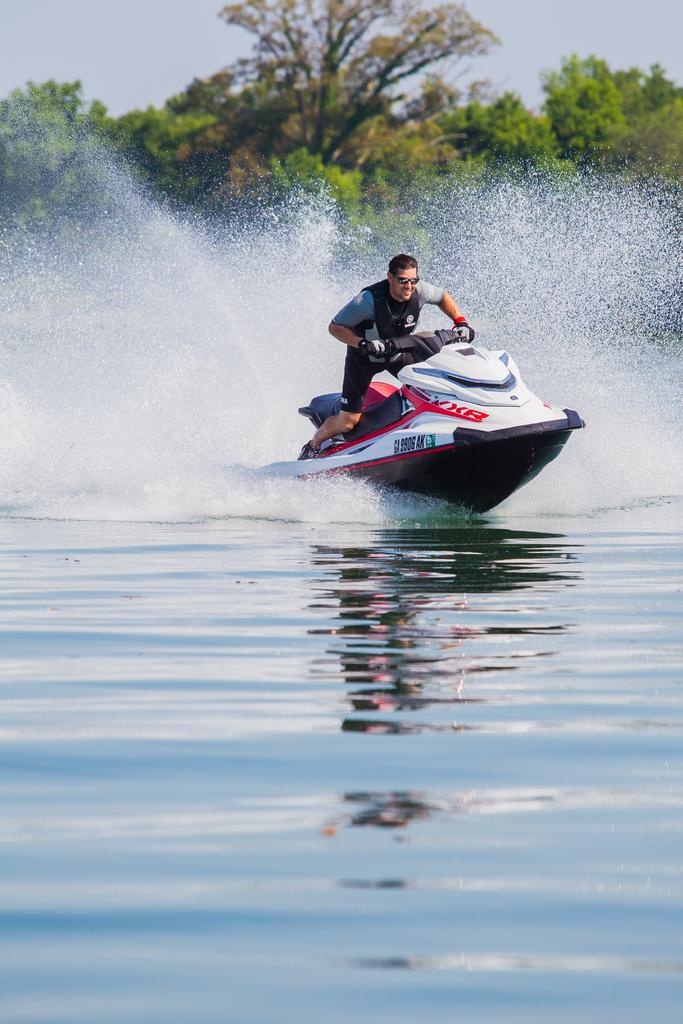What is the person in the image doing? There is a person on a speedboat in the image. What colors can be seen on the speedboat? The speedboat is in white, red, and black colors. What is the color of the water in the image? There is blue-colored water in the image. What type of natural environment is visible in the image? Trees are visible in the image. What else can be seen in the sky in the image? The sky is visible in the image. What type of locket is the person wearing on their neck in the image? There is no locket visible on the person in the image. Can you describe the ring the person is wearing on their finger in the image? There is no ring visible on the person in the image. 